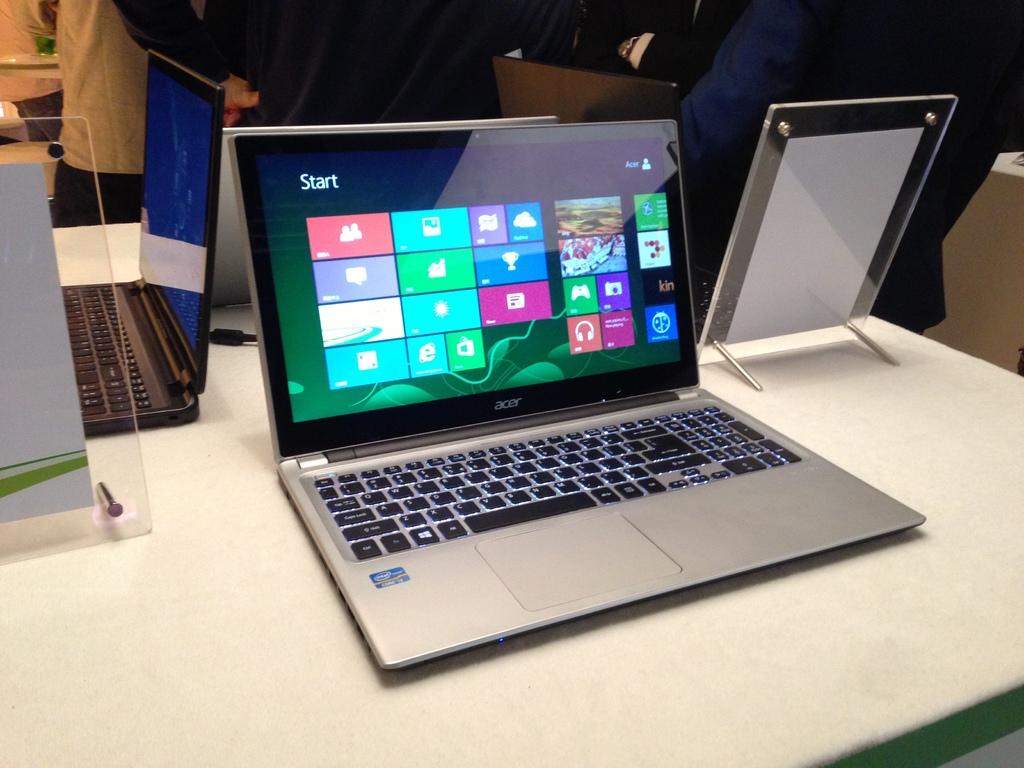<image>
Give a short and clear explanation of the subsequent image. an Acer laptop open to the windows start screen. 